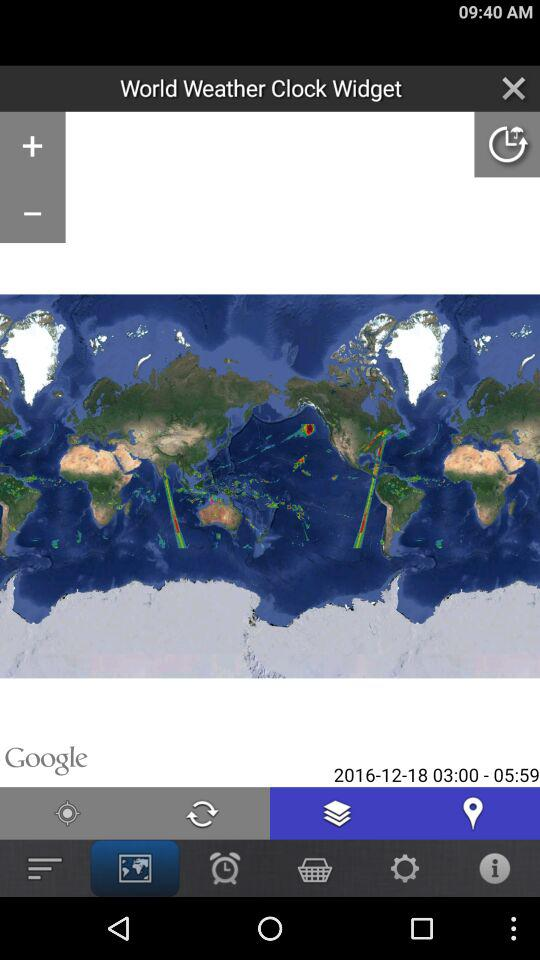What's the mentioned date? The mentioned date is December 18, 2016. 